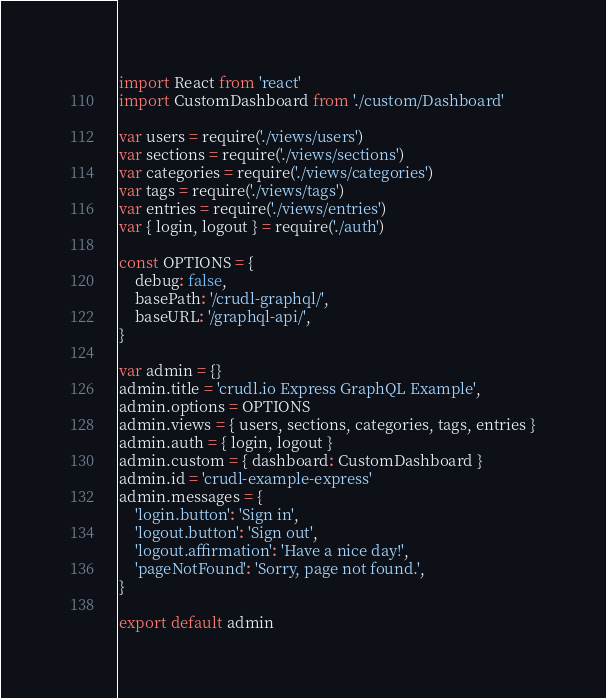<code> <loc_0><loc_0><loc_500><loc_500><_JavaScript_>import React from 'react'
import CustomDashboard from './custom/Dashboard'

var users = require('./views/users')
var sections = require('./views/sections')
var categories = require('./views/categories')
var tags = require('./views/tags')
var entries = require('./views/entries')
var { login, logout } = require('./auth')

const OPTIONS = {
    debug: false,
    basePath: '/crudl-graphql/',
    baseURL: '/graphql-api/',
}

var admin = {}
admin.title = 'crudl.io Express GraphQL Example',
admin.options = OPTIONS
admin.views = { users, sections, categories, tags, entries }
admin.auth = { login, logout }
admin.custom = { dashboard: CustomDashboard }
admin.id = 'crudl-example-express'
admin.messages = {
    'login.button': 'Sign in',
    'logout.button': 'Sign out',
    'logout.affirmation': 'Have a nice day!',
    'pageNotFound': 'Sorry, page not found.',
}

export default admin
</code> 